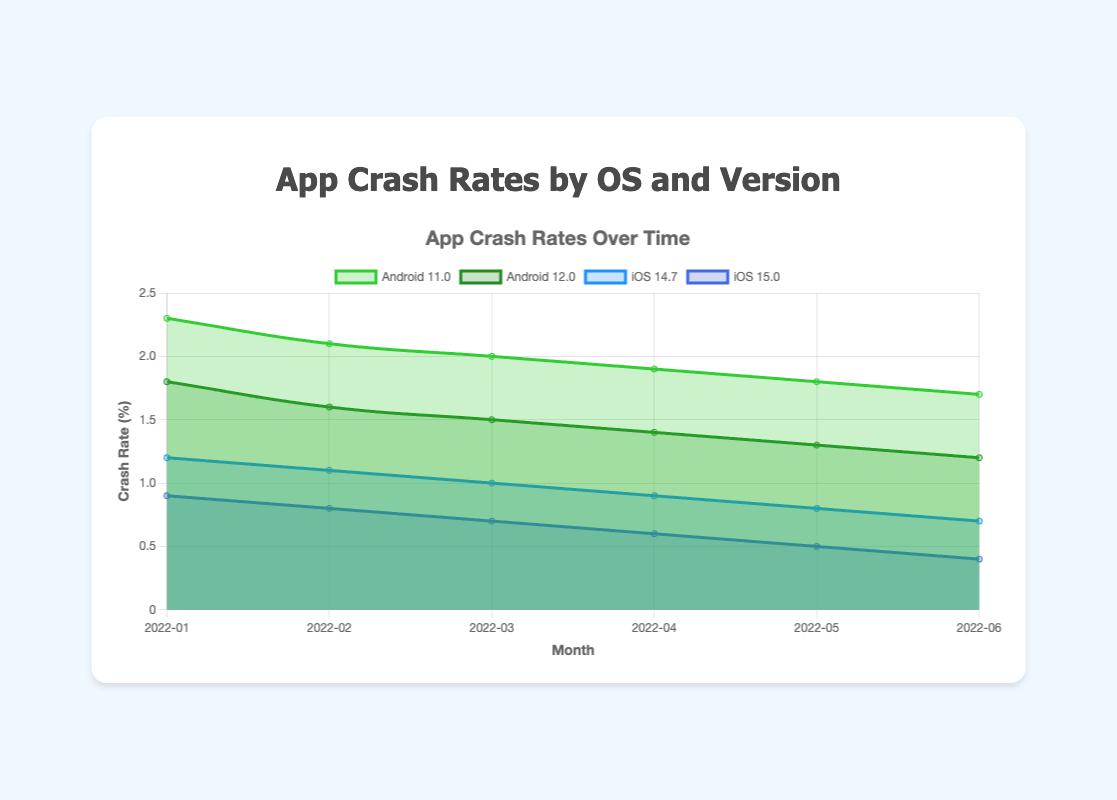Which operating system and version had the highest crash rate in January 2022? By looking at January 2022 data points, compare the crash rates for Android 11.0, Android 12.0, iOS 14.7, and iOS 15.0. Android 11.0 has the highest crash rate of 2.3%.
Answer: Android 11.0 How did the crash rate for iOS 15.0 change from February 2022 to March 2022? Compare the crash rate value for iOS 15.0 in February (0.8%) to March (0.7%). The crash rate decreased by 0.1%.
Answer: Decreased by 0.1% What was the average crash rate for Android 12.0 from January to June 2022? Add the crash rates for Android 12.0 for each month (1.8 + 1.6 + 1.5 + 1.4 + 1.3 + 1.2) and divide by the number of months (6). The sum is 8.8, so the average is 8.8/6 = 1.47%.
Answer: 1.47% Which version of iOS had a consistently lower crash rate over time, 14.7 or 15.0? Compare the month-to-month crash rates for iOS 14.7 and 15.0. iOS 15.0 consistently has lower rates each month.
Answer: iOS 15.0 During which month did the crash rate for Android 11.0 see the largest single-month drop? Evaluate the month-to-month differences for Android 11.0 crash rates. The largest drop is from January (2.3%) to February (2.1%) by 0.2%.
Answer: January to February 2022 Between May 2022 and June 2022, which operating system version showed more improvement (reduction in crash rate), Android 11.0 or iOS 14.7? Compare the reduction in crash rates: Android 11.0 (1.8% to 1.7%) improved by 0.1%, iOS 14.7 (0.8% to 0.7%) improved by 0.1%. Both improved equally.
Answer: Both improved equally What is the overall trend in crash rates for Android 12.0 from January to June 2022? Observe the crash rates for Android 12.0 from month to month: 1.8%, 1.6%, 1.5%, 1.4%, 1.3%, and 1.2%. The overall trend is a continuous decrease.
Answer: Decreasing In June 2022, which operating system version had the lowest crash rate? Examine the crash rates for all versions in June 2022. iOS 15.0 has the lowest rate of 0.4%.
Answer: iOS 15.0 By how much did the crash rate for iOS 14.7 decrease from January 2022 to June 2022? Compare the crash rates for iOS 14.7 from January (1.2%) to June (0.7%). The decrease is 1.2% - 0.7% = 0.5%.
Answer: 0.5% 